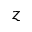<formula> <loc_0><loc_0><loc_500><loc_500>z</formula> 